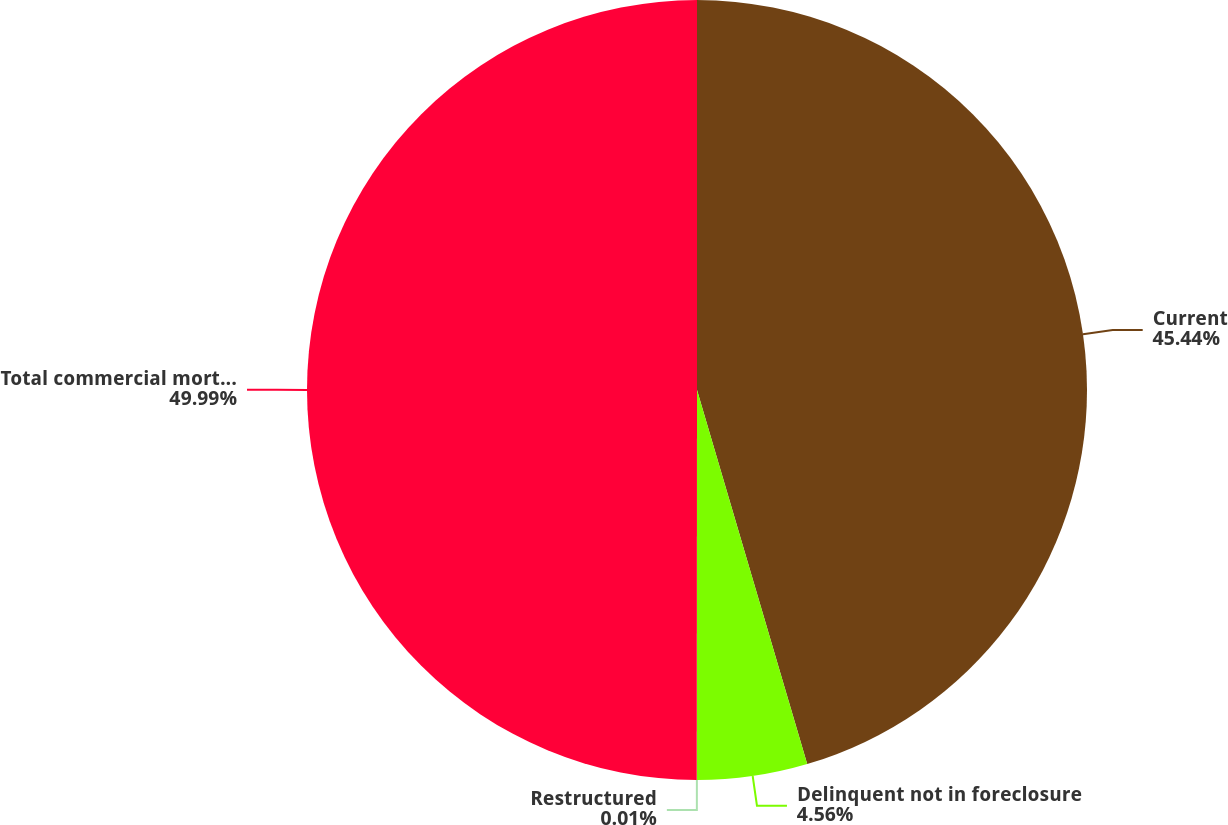<chart> <loc_0><loc_0><loc_500><loc_500><pie_chart><fcel>Current<fcel>Delinquent not in foreclosure<fcel>Restructured<fcel>Total commercial mortgage and<nl><fcel>45.44%<fcel>4.56%<fcel>0.01%<fcel>49.99%<nl></chart> 